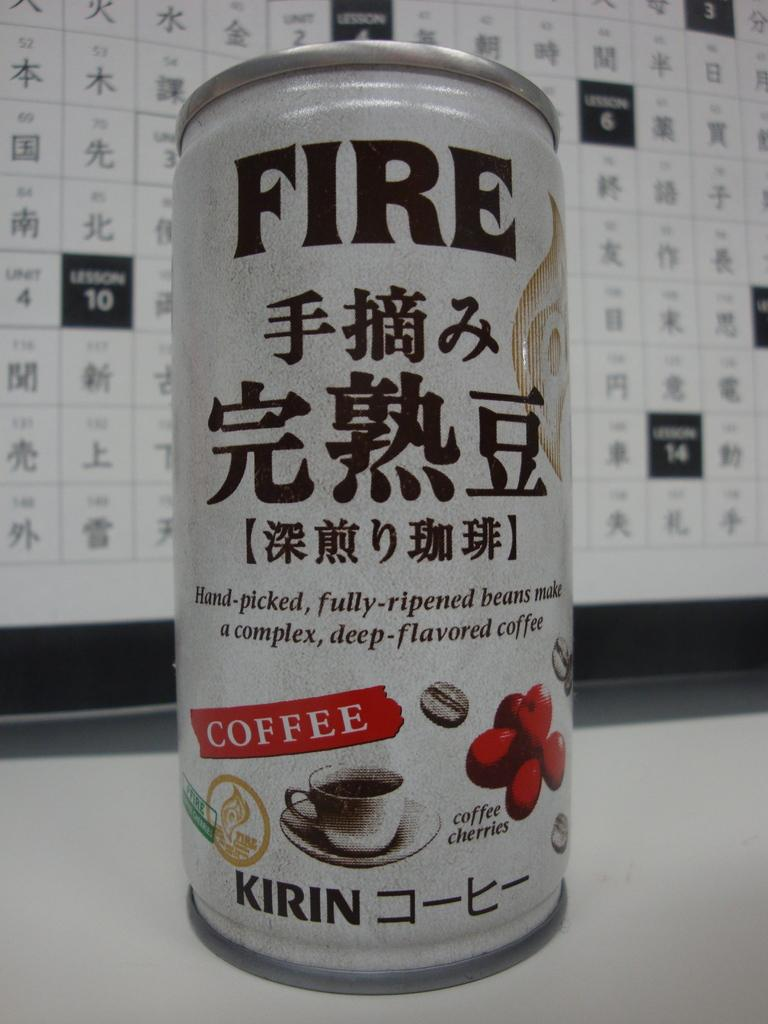<image>
Create a compact narrative representing the image presented. A can of Fire coffee with a chart in the background. 